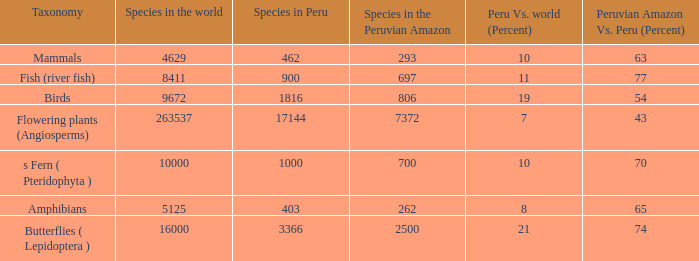What's the minimum species in the peruvian amazon with peru vs. world (percent) value of 7 7372.0. 